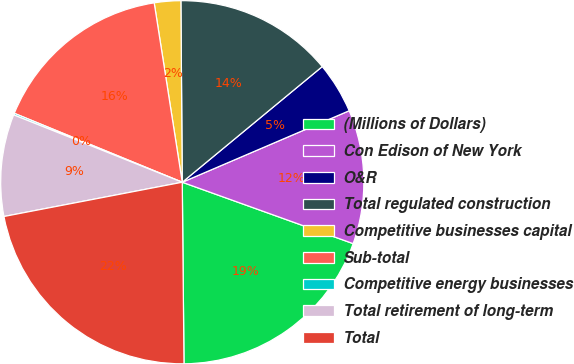Convert chart. <chart><loc_0><loc_0><loc_500><loc_500><pie_chart><fcel>(Millions of Dollars)<fcel>Con Edison of New York<fcel>O&R<fcel>Total regulated construction<fcel>Competitive businesses capital<fcel>Sub-total<fcel>Competitive energy businesses<fcel>Total retirement of long-term<fcel>Total<nl><fcel>19.36%<fcel>11.93%<fcel>4.55%<fcel>14.13%<fcel>2.35%<fcel>16.33%<fcel>0.15%<fcel>9.07%<fcel>22.13%<nl></chart> 